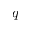<formula> <loc_0><loc_0><loc_500><loc_500>q</formula> 